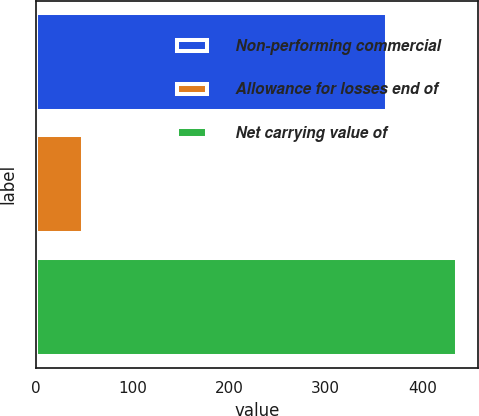<chart> <loc_0><loc_0><loc_500><loc_500><bar_chart><fcel>Non-performing commercial<fcel>Allowance for losses end of<fcel>Net carrying value of<nl><fcel>364<fcel>49<fcel>436<nl></chart> 